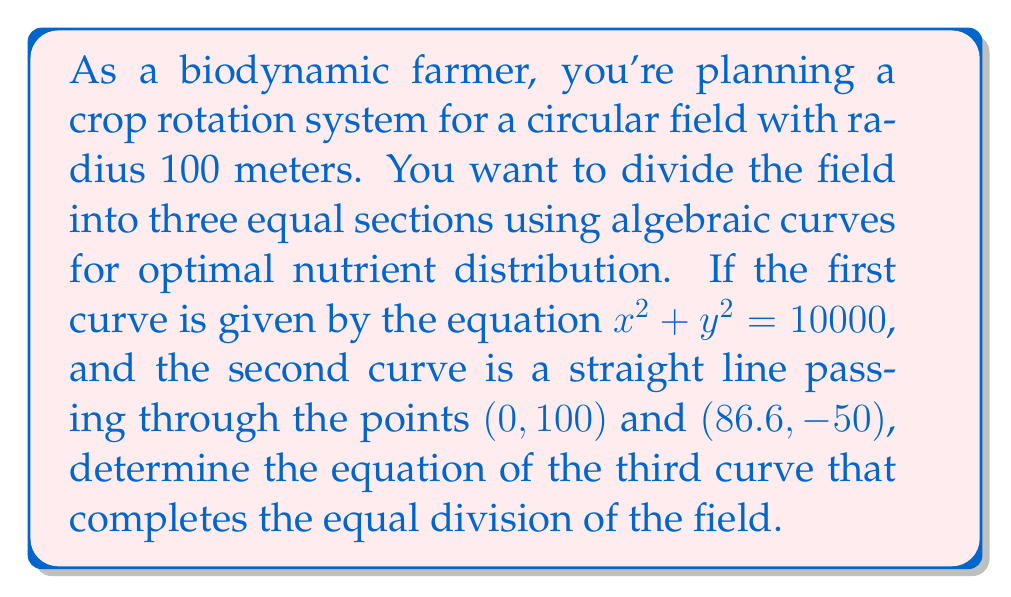Teach me how to tackle this problem. Let's approach this step-by-step:

1) The first curve $x^2 + y^2 = 10000$ is the equation of the circular field with radius 100 meters.

2) The second curve is a straight line. We can find its equation using the point-slope form:

   $y - y_1 = m(x - x_1)$

   where $m = \frac{y_2 - y_1}{x_2 - x_1} = \frac{-50 - 100}{86.6 - 0} = -1.732$

   Substituting the point (0, 100) and the slope:

   $y - 100 = -1.732x$
   $y = -1.732x + 100$

3) For the field to be divided equally, each curve should pass through the center (0, 0) and create a 120° angle with the other curves.

4) The third curve should be symmetric to the second curve with respect to the y-axis. We can obtain its equation by replacing x with -x in the equation of the second curve:

   $y = 1.732x + 100$

5) To verify, let's check if this creates three equal sections:
   - Angle between $x$-axis and $y = -1.732x + 100$: $\arctan(1.732) = 60°$
   - Angle between $x$-axis and $y = 1.732x + 100$: $180° - \arctan(1.732) = 120°$
   - Remaining angle: $360° - 120° - 60° = 180°$

   This confirms the equal division.

6) Therefore, the equation of the third curve is $y = 1.732x + 100$.
Answer: $y = 1.732x + 100$ 